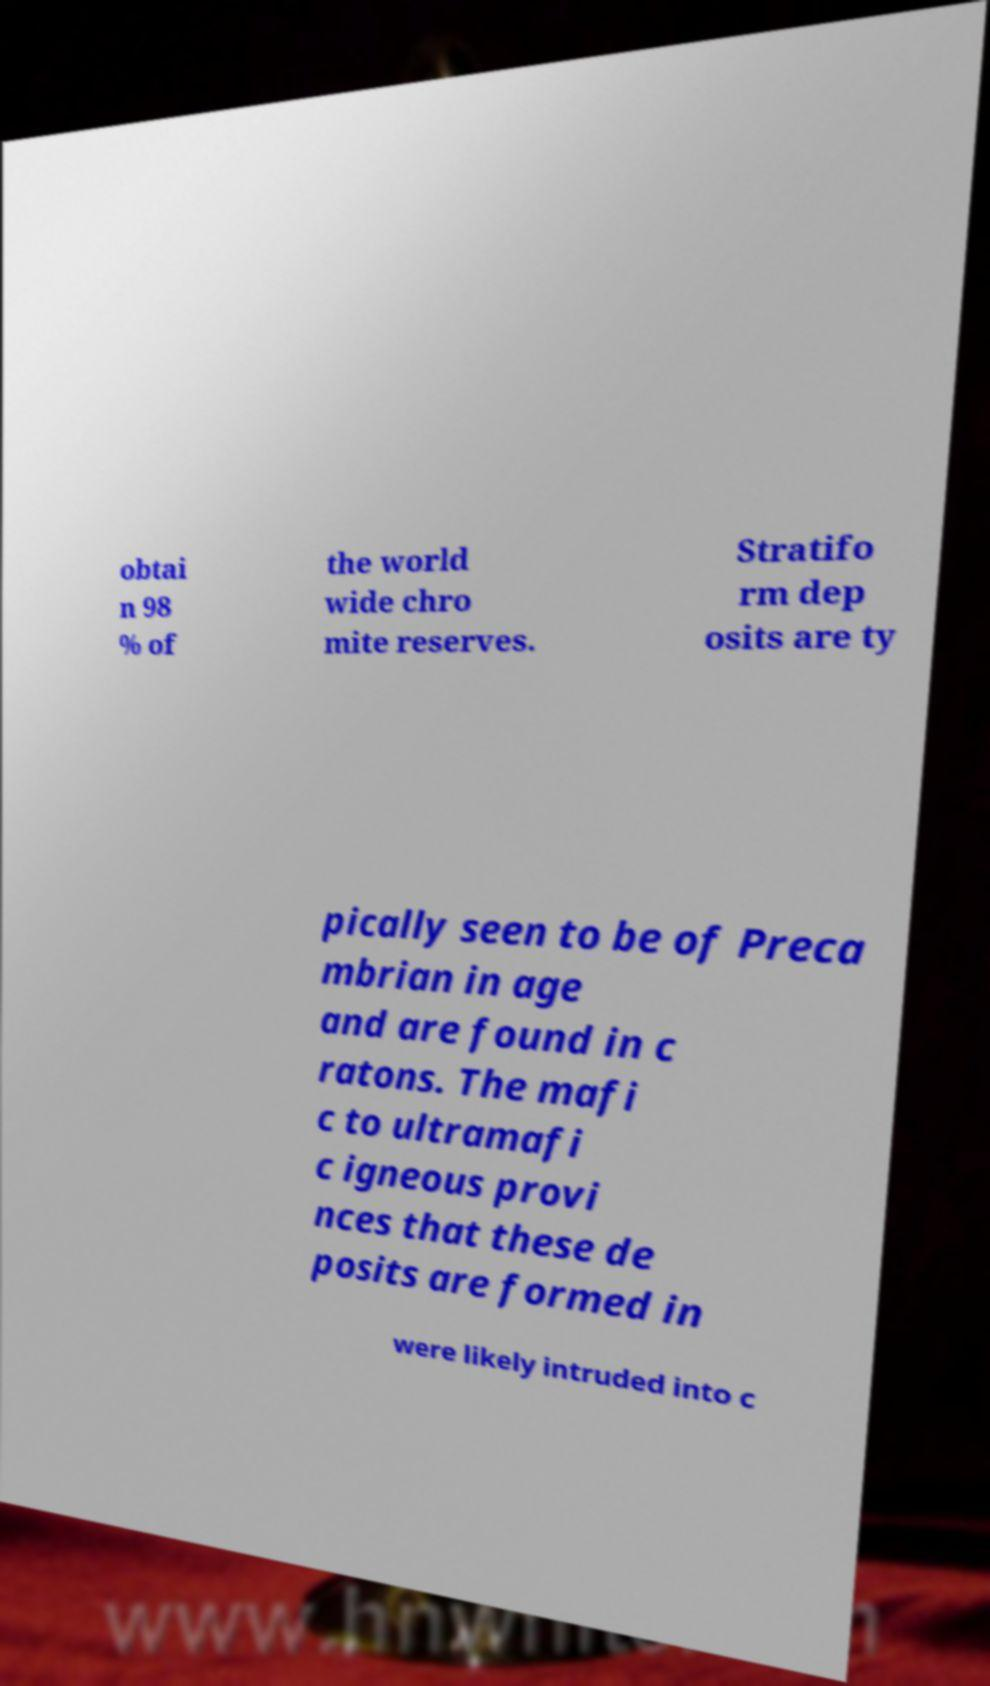Could you extract and type out the text from this image? obtai n 98 % of the world wide chro mite reserves. Stratifo rm dep osits are ty pically seen to be of Preca mbrian in age and are found in c ratons. The mafi c to ultramafi c igneous provi nces that these de posits are formed in were likely intruded into c 